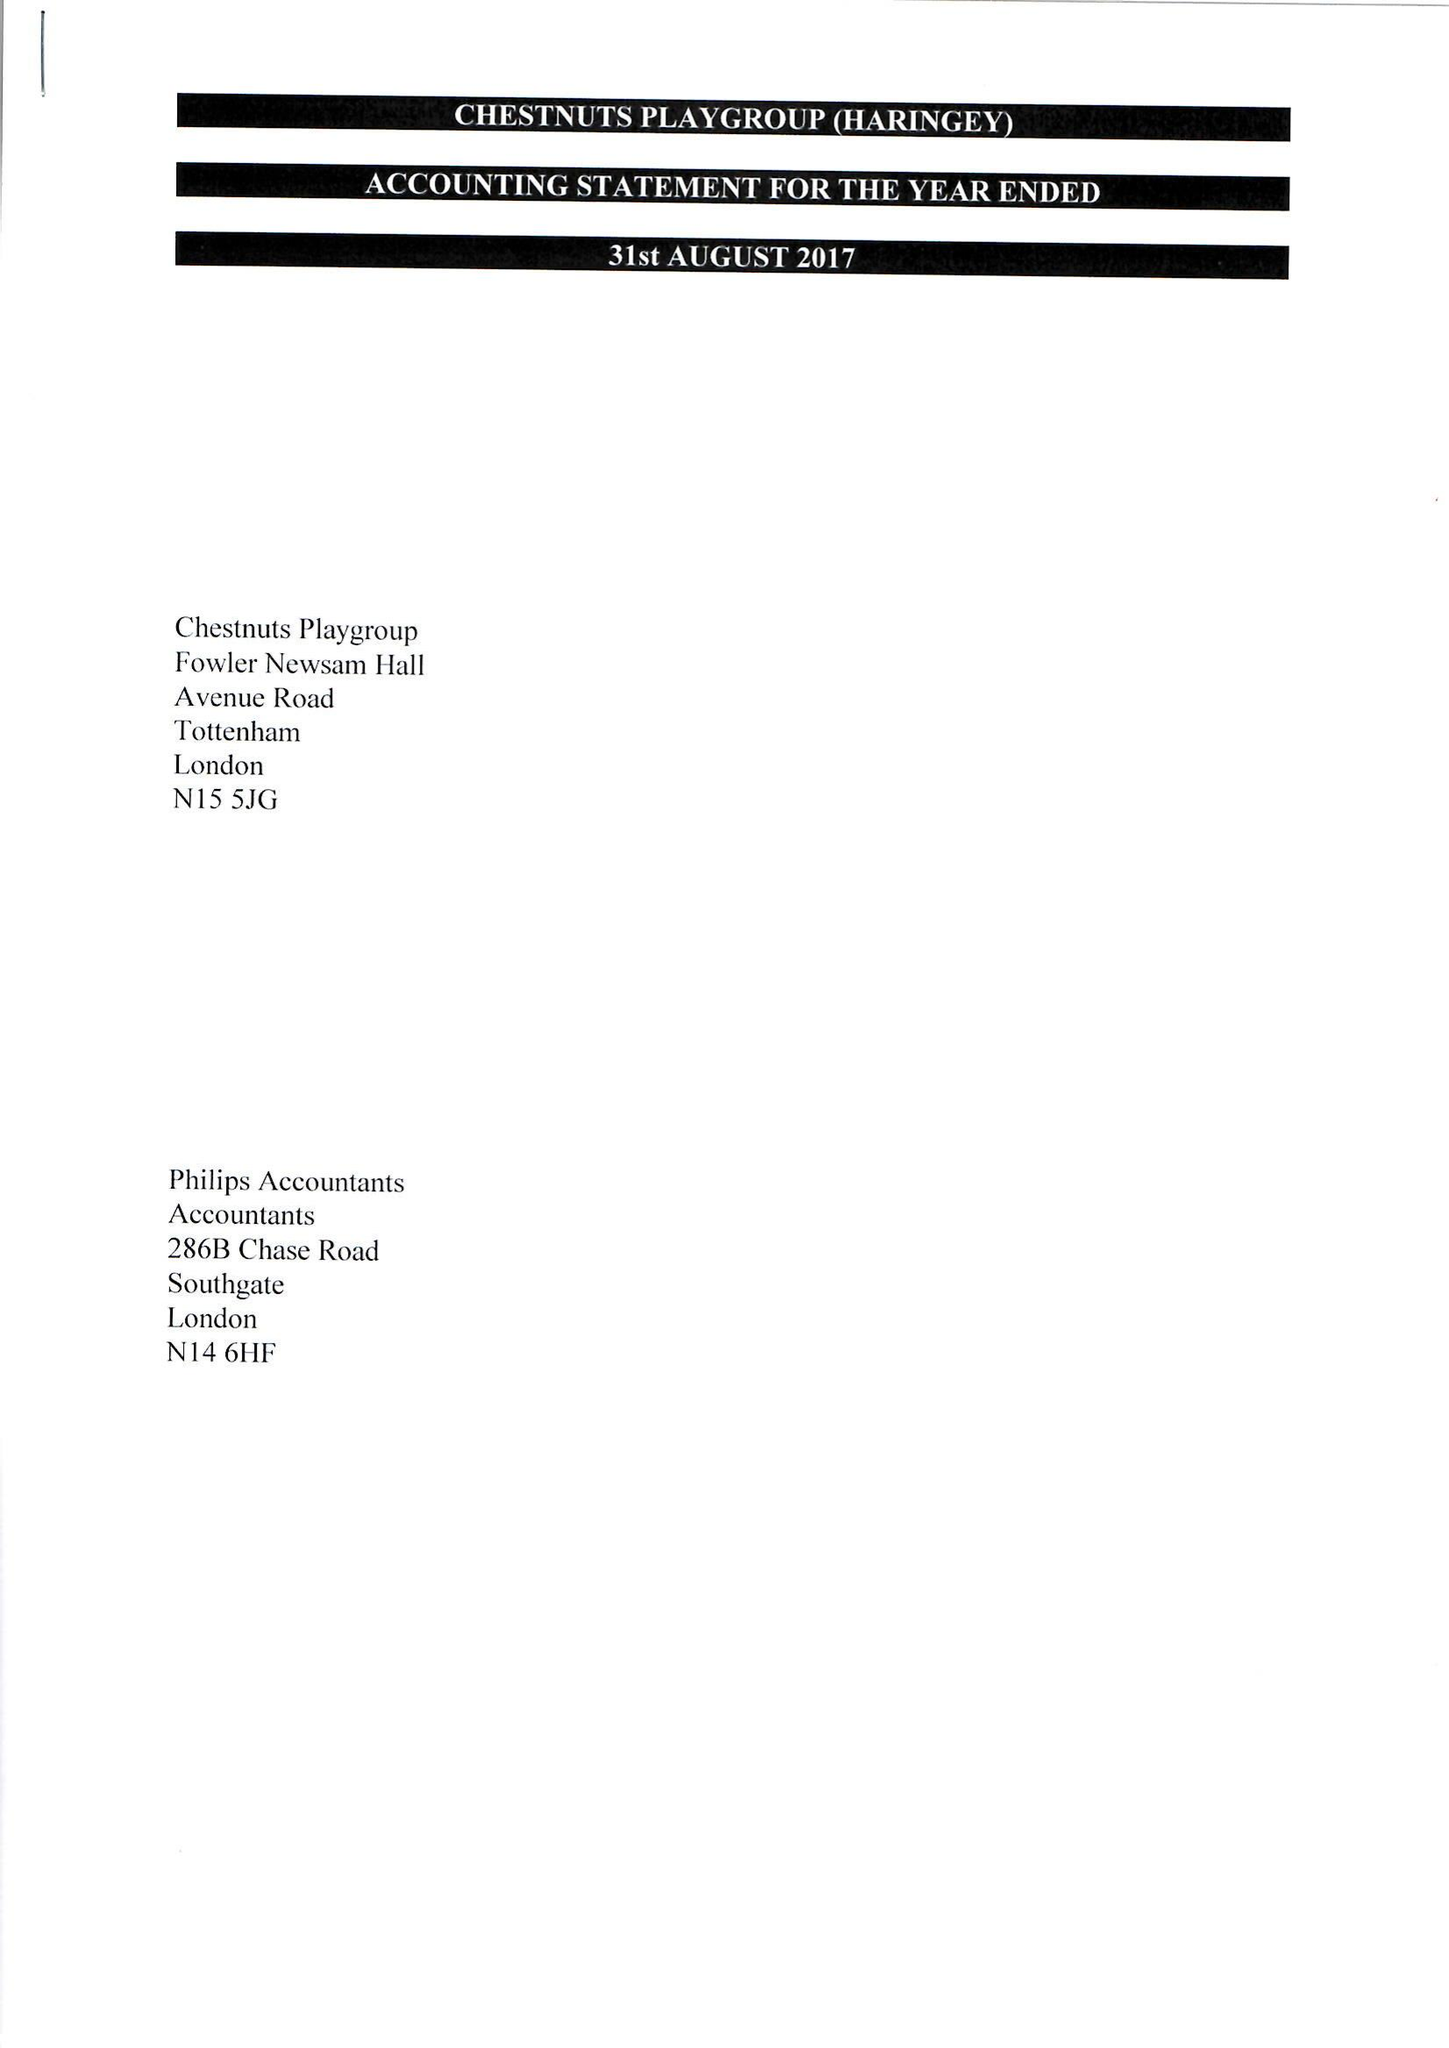What is the value for the address__postcode?
Answer the question using a single word or phrase. N15 5JG 